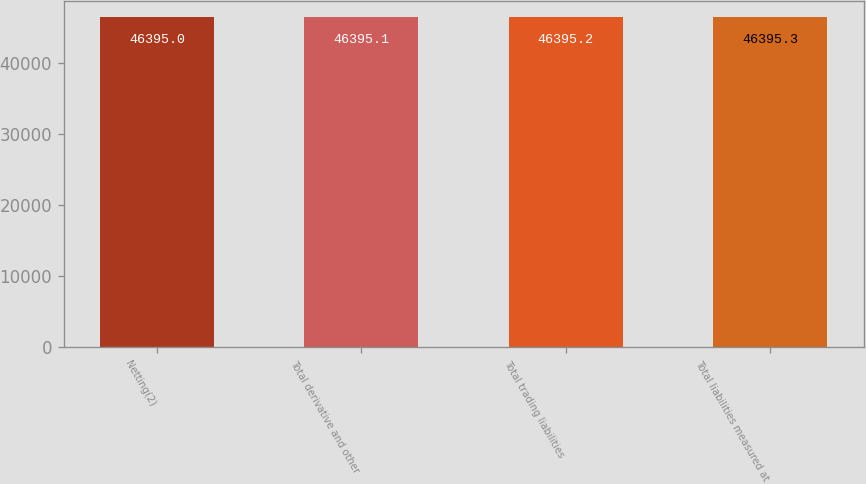Convert chart to OTSL. <chart><loc_0><loc_0><loc_500><loc_500><bar_chart><fcel>Netting(2)<fcel>Total derivative and other<fcel>Total trading liabilities<fcel>Total liabilities measured at<nl><fcel>46395<fcel>46395.1<fcel>46395.2<fcel>46395.3<nl></chart> 